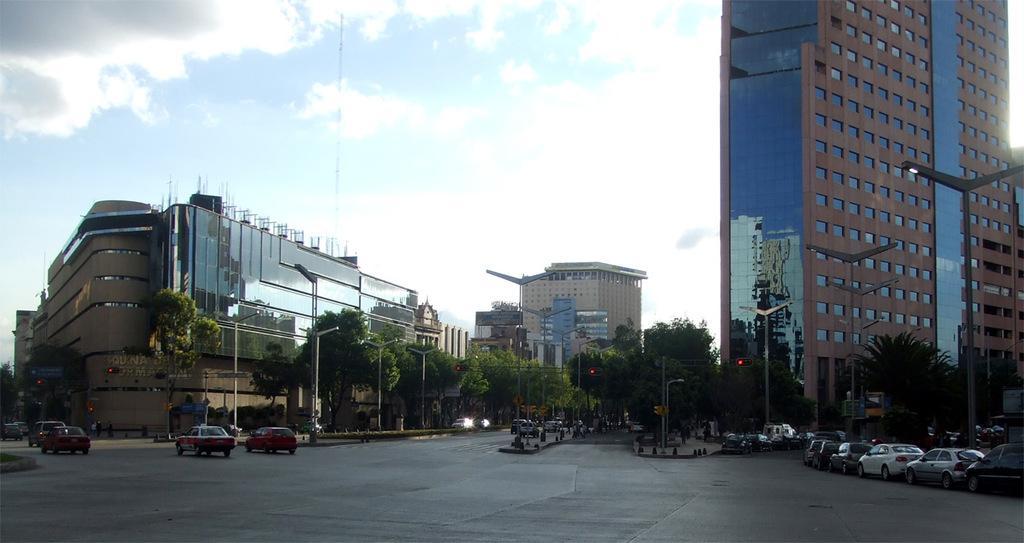Please provide a concise description of this image. In this image we can see cars, trees, street lights, road and buildings. The sky is in blue color with clouds. 